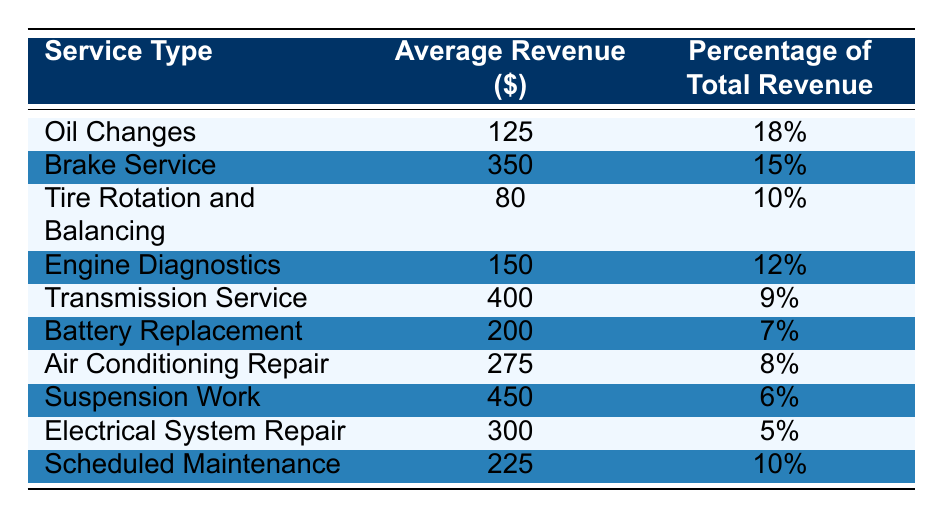What is the average revenue from Oil Changes? The table lists the average revenue from Oil Changes as $125.
Answer: 125 What percentage of total revenue does Brake Service contribute? According to the table, Brake Service contributes 15% of the total revenue.
Answer: 15% Which service type has the highest average revenue? Suspension Work has the highest average revenue at $450 according to the table.
Answer: Suspension Work What is the total percentage of revenue contributed by Engine Diagnostics and Tire Rotation and Balancing? Engine Diagnostics contributes 12% and Tire Rotation and Balancing contributes 10%. Adding these gives 12% + 10% = 22%.
Answer: 22% Is the average revenue from Battery Replacement higher than that of Air Conditioning Repair? The average revenue for Battery Replacement is $200, while for Air Conditioning Repair it is $275. Since $200 is less than $275, the statement is false.
Answer: No What is the average revenue across all service types listed in the table? To find the average revenue, sum all the average revenues: 125 + 350 + 80 + 150 + 400 + 200 + 275 + 450 + 300 + 225 = 2260. Then, divide by the number of service types (10), which equals 2260 / 10 = 226.
Answer: 226 Which service type represents the lowest percentage of total revenue? The service type with the lowest percentage of total revenue is Electrical System Repair, with 5%.
Answer: Electrical System Repair If you remove the Tire Rotation and Balancing revenue from the total, what percentage does that represent? Firstly, Tire Rotation and Balancing revenue is $80. The total revenue before removing it is $2260. Removing it gives 2260 - 80 = 2180. The percentage contribution from Tire Rotation and Balancing is (80 / 2260) * 100, which is approximately 3.54%.
Answer: Approximately 3.54% How much revenue is generated from the services with less than 10% contribution? Services with less than 10% contribution are Transmission Service, Battery Replacement, Suspension Work, and Electrical System Repair. Their average revenues are $400, $200, $450, and $300 respectively. The total is 400 + 200 + 450 + 300 = 1350.
Answer: 1350 Is the revenue from Scheduled Maintenance closer to that of Oil Changes or Brake Service? Scheduled Maintenance has an average revenue of $225, Oil Changes has $125, and Brake Service has $350. The difference between Scheduled Maintenance and Oil Changes is 225 - 125 = 100, while the difference to Brake Service is 350 - 225 = 125. Since 100 is less, it is closer to Oil Changes.
Answer: Closer to Oil Changes 